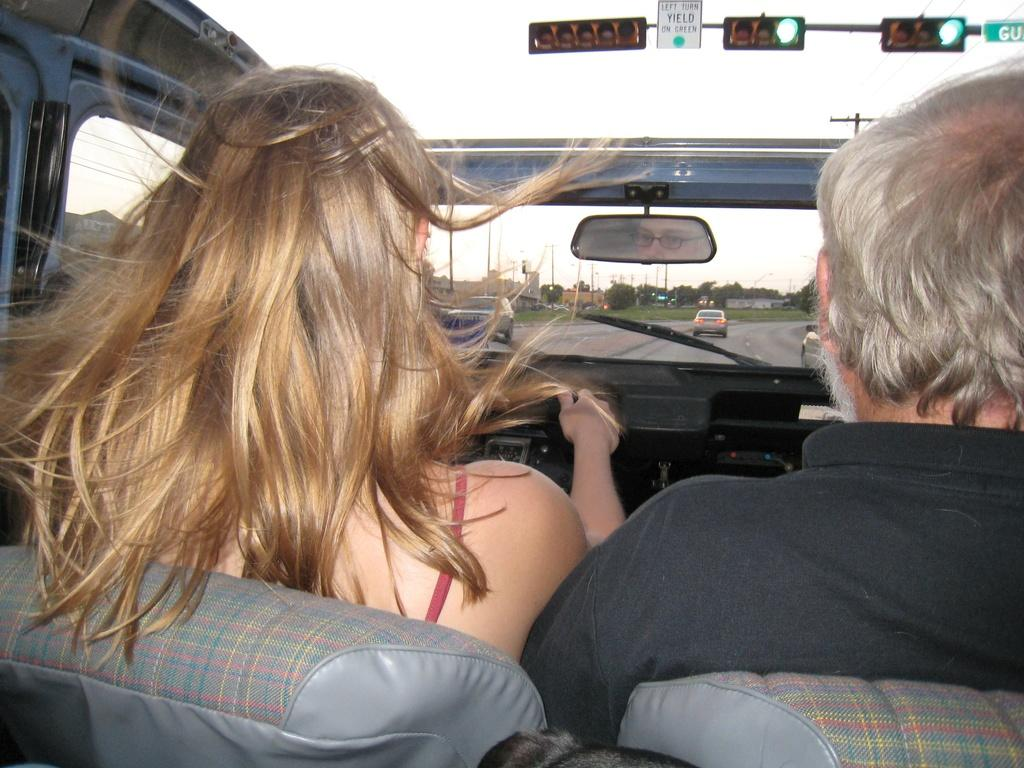Where was the image taken? The image is taken outdoors. How many people are in the image? There are two people in the image. What are the people doing in the image? The people are sitting on a car. What is the car doing in the image? The car is moving on a road. What can be seen in front of the people? There are trees, at least one building, and traffic lights in front of the people. What part of the natural environment is visible in the image? The sky is visible in the image. What type of hook can be seen in the image? There is no hook present in the image. Are the police involved in the scene depicted in the image? There is no indication of police involvement in the image. 